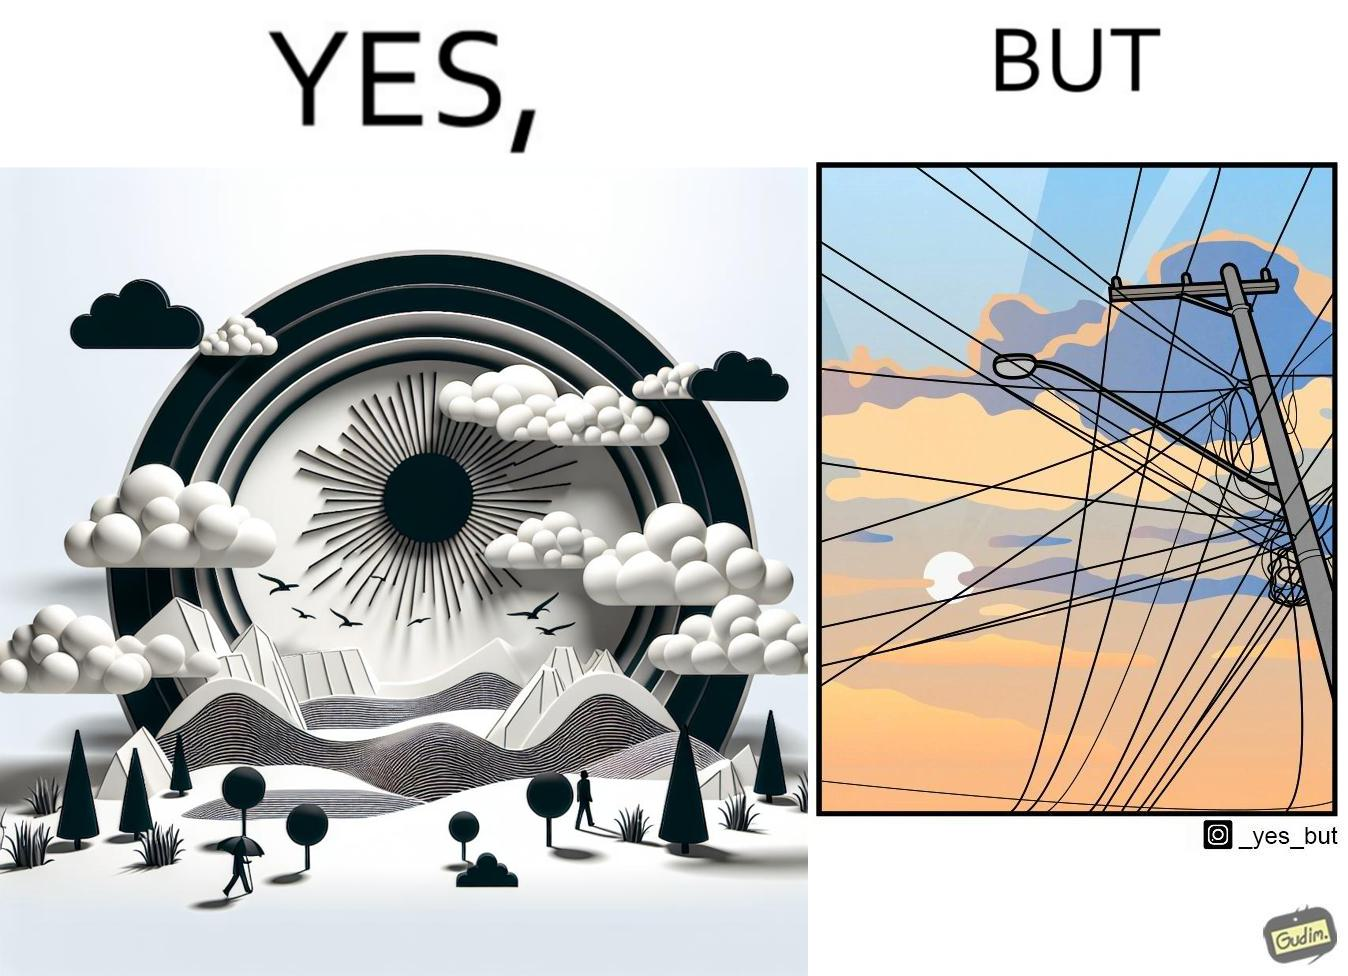Describe the contrast between the left and right parts of this image. In the left part of the image: a clear sky with sun and clouds In the right part of the image: an electricity pole with a lot of wires over it 